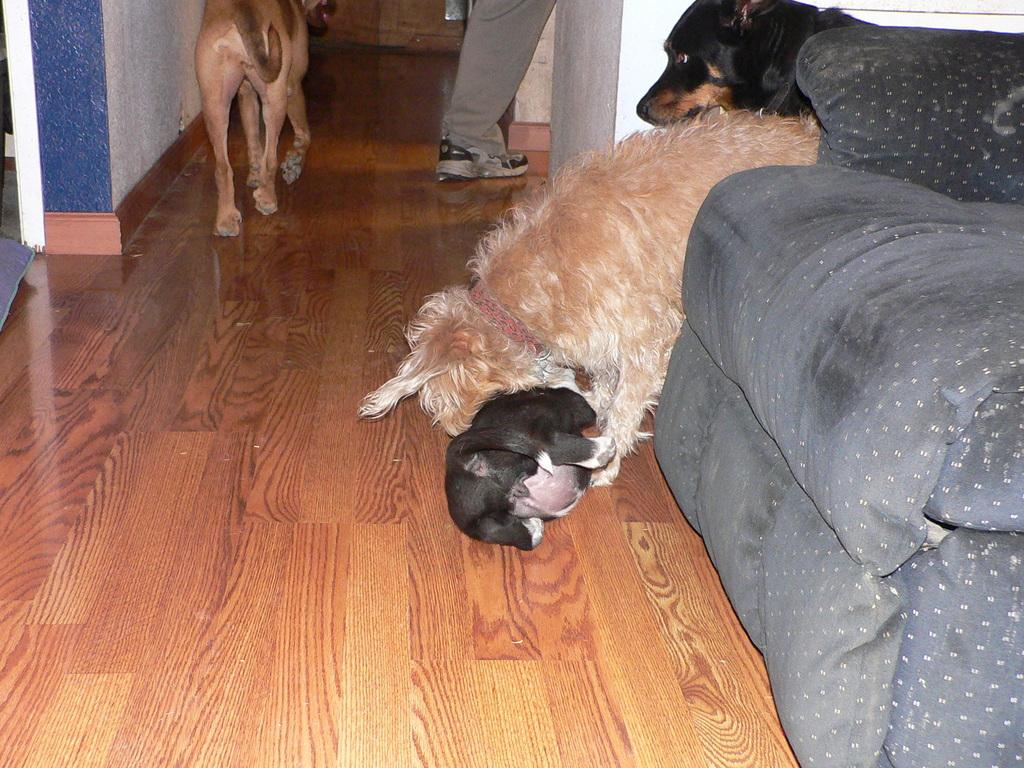What type of furniture is on the right side of the image? There is a sofa on the right side of the image. What animals are near the sofa? There are dogs near the sofa. Are there any other dogs visible in the image? Yes, there is another dog in the background of the image. Can you describe any part of a person in the image? A person's leg is visible in the image. What type of structure is present in the image encloses the space? There are walls in the image. What type of stew is being prepared in the image? There is no indication of any stew being prepared in the image. Can you describe the land in the image? The image does not show any land; it is focused on the sofa, dogs, and person's leg. 